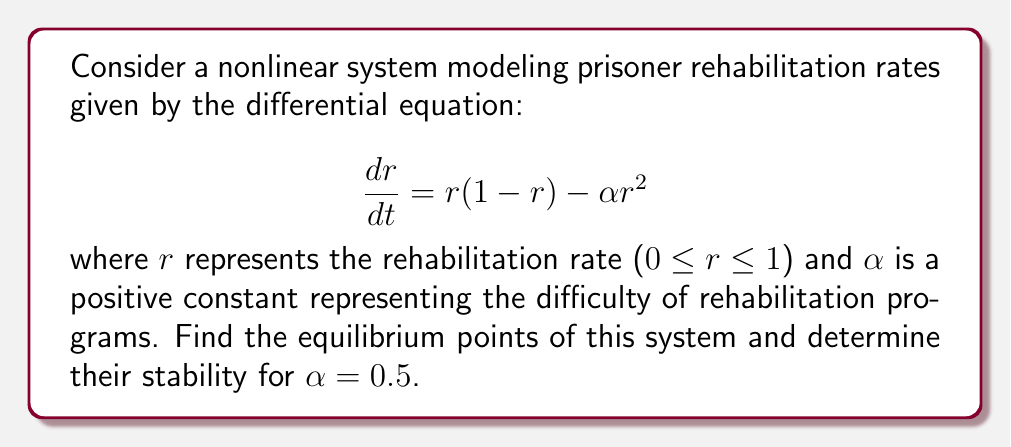What is the answer to this math problem? 1. To find the equilibrium points, set $\frac{dr}{dt} = 0$:
   $$r(1-r) - \alpha r^2 = 0$$

2. Substitute $\alpha = 0.5$:
   $$r(1-r) - 0.5r^2 = 0$$

3. Factor out $r$:
   $$r(1-r-0.5r) = r(1-1.5r) = 0$$

4. Solve for $r$:
   $r = 0$ or $1-1.5r = 0$
   $r = 0$ or $r = \frac{2}{3}$

5. To determine stability, calculate $\frac{d}{dr}(\frac{dr}{dt})$ at each equilibrium point:
   $$\frac{d}{dr}(\frac{dr}{dt}) = 1 - 2r - 2\alpha r = 1 - 2r - r = 1 - 3r$$

6. At $r = 0$:
   $1 - 3(0) = 1 > 0$, so $r = 0$ is unstable.

7. At $r = \frac{2}{3}$:
   $1 - 3(\frac{2}{3}) = -1 < 0$, so $r = \frac{2}{3}$ is stable.
Answer: Equilibrium points: $r = 0$ (unstable) and $r = \frac{2}{3}$ (stable). 